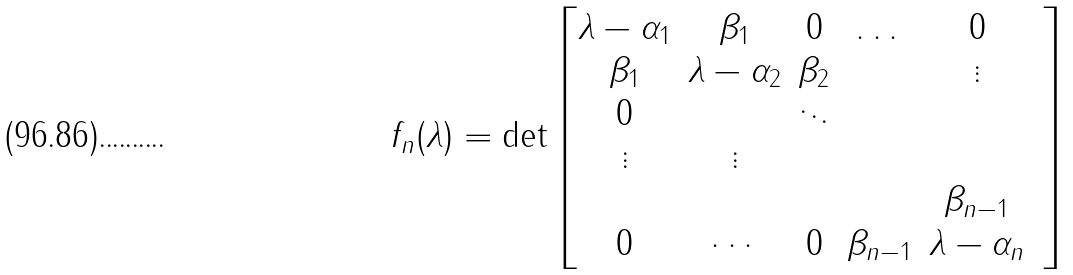Convert formula to latex. <formula><loc_0><loc_0><loc_500><loc_500>f _ { n } ( \lambda ) = \det \begin{bmatrix} \lambda - \alpha _ { 1 } & \beta _ { 1 } & 0 & \dots & 0 \\ \beta _ { 1 } & \lambda - \alpha _ { 2 } & \beta _ { 2 } & & \vdots \\ 0 & & \ddots & & \\ \vdots & \vdots & & & & \\ & & & & \beta _ { n - 1 } \\ 0 & \cdots & 0 & \beta _ { n - 1 } & \lambda - \alpha _ { n } \end{bmatrix}</formula> 